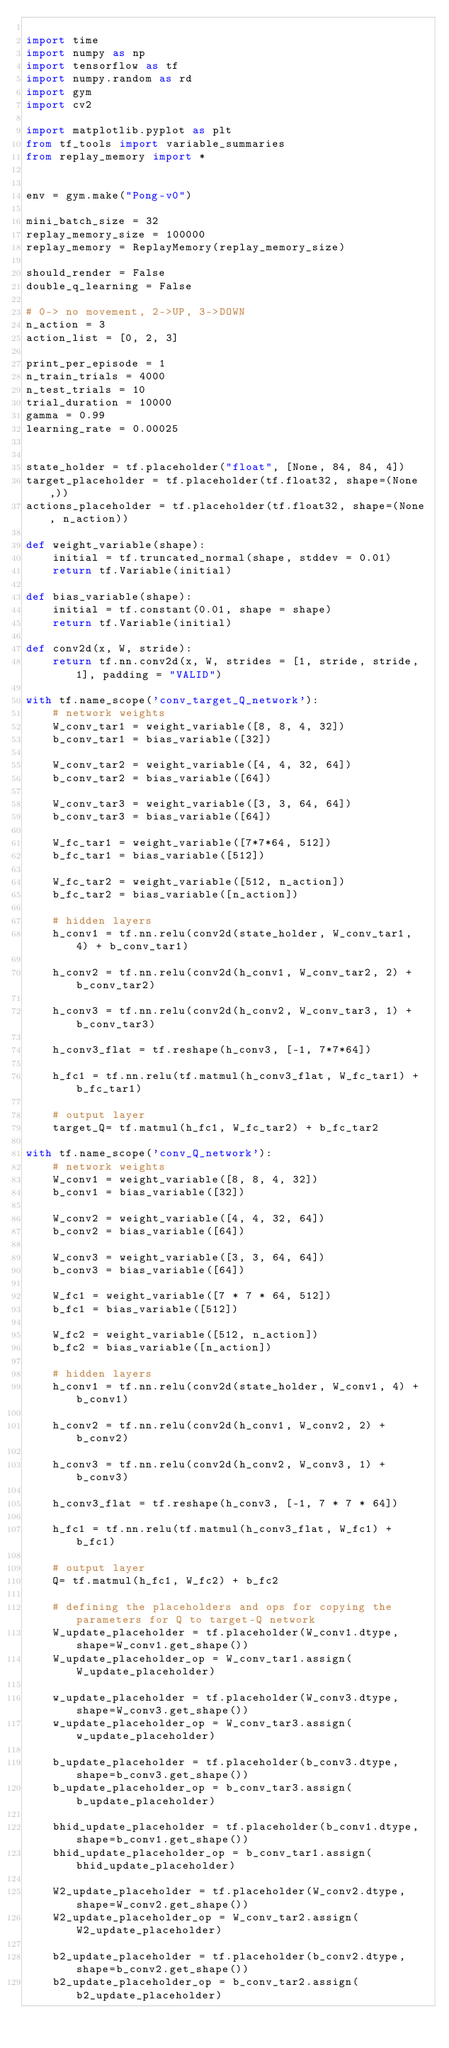Convert code to text. <code><loc_0><loc_0><loc_500><loc_500><_Python_>
import time
import numpy as np
import tensorflow as tf
import numpy.random as rd
import gym
import cv2

import matplotlib.pyplot as plt
from tf_tools import variable_summaries
from replay_memory import *


env = gym.make("Pong-v0")

mini_batch_size = 32
replay_memory_size = 100000
replay_memory = ReplayMemory(replay_memory_size)

should_render = False
double_q_learning = False

# 0-> no movement, 2->UP, 3->DOWN
n_action = 3
action_list = [0, 2, 3]

print_per_episode = 1
n_train_trials = 4000
n_test_trials = 10
trial_duration = 10000
gamma = 0.99
learning_rate = 0.00025


state_holder = tf.placeholder("float", [None, 84, 84, 4])
target_placeholder = tf.placeholder(tf.float32, shape=(None,))
actions_placeholder = tf.placeholder(tf.float32, shape=(None, n_action))

def weight_variable(shape):
    initial = tf.truncated_normal(shape, stddev = 0.01)
    return tf.Variable(initial)

def bias_variable(shape):
    initial = tf.constant(0.01, shape = shape)
    return tf.Variable(initial)

def conv2d(x, W, stride):
    return tf.nn.conv2d(x, W, strides = [1, stride, stride, 1], padding = "VALID")

with tf.name_scope('conv_target_Q_network'):
    # network weights
    W_conv_tar1 = weight_variable([8, 8, 4, 32])
    b_conv_tar1 = bias_variable([32])

    W_conv_tar2 = weight_variable([4, 4, 32, 64])
    b_conv_tar2 = bias_variable([64])

    W_conv_tar3 = weight_variable([3, 3, 64, 64])
    b_conv_tar3 = bias_variable([64])

    W_fc_tar1 = weight_variable([7*7*64, 512])
    b_fc_tar1 = bias_variable([512])

    W_fc_tar2 = weight_variable([512, n_action])
    b_fc_tar2 = bias_variable([n_action])

    # hidden layers
    h_conv1 = tf.nn.relu(conv2d(state_holder, W_conv_tar1, 4) + b_conv_tar1)

    h_conv2 = tf.nn.relu(conv2d(h_conv1, W_conv_tar2, 2) + b_conv_tar2)

    h_conv3 = tf.nn.relu(conv2d(h_conv2, W_conv_tar3, 1) + b_conv_tar3)

    h_conv3_flat = tf.reshape(h_conv3, [-1, 7*7*64])

    h_fc1 = tf.nn.relu(tf.matmul(h_conv3_flat, W_fc_tar1) + b_fc_tar1)

    # output layer
    target_Q= tf.matmul(h_fc1, W_fc_tar2) + b_fc_tar2

with tf.name_scope('conv_Q_network'):
    # network weights
    W_conv1 = weight_variable([8, 8, 4, 32])
    b_conv1 = bias_variable([32])

    W_conv2 = weight_variable([4, 4, 32, 64])
    b_conv2 = bias_variable([64])

    W_conv3 = weight_variable([3, 3, 64, 64])
    b_conv3 = bias_variable([64])

    W_fc1 = weight_variable([7 * 7 * 64, 512])
    b_fc1 = bias_variable([512])

    W_fc2 = weight_variable([512, n_action])
    b_fc2 = bias_variable([n_action])

    # hidden layers
    h_conv1 = tf.nn.relu(conv2d(state_holder, W_conv1, 4) + b_conv1)

    h_conv2 = tf.nn.relu(conv2d(h_conv1, W_conv2, 2) + b_conv2)

    h_conv3 = tf.nn.relu(conv2d(h_conv2, W_conv3, 1) + b_conv3)

    h_conv3_flat = tf.reshape(h_conv3, [-1, 7 * 7 * 64])

    h_fc1 = tf.nn.relu(tf.matmul(h_conv3_flat, W_fc1) + b_fc1)

    # output layer
    Q= tf.matmul(h_fc1, W_fc2) + b_fc2

    # defining the placeholders and ops for copying the parameters for Q to target-Q network
    W_update_placeholder = tf.placeholder(W_conv1.dtype, shape=W_conv1.get_shape())
    W_update_placeholder_op = W_conv_tar1.assign(W_update_placeholder)

    w_update_placeholder = tf.placeholder(W_conv3.dtype, shape=W_conv3.get_shape())
    w_update_placeholder_op = W_conv_tar3.assign(w_update_placeholder)

    b_update_placeholder = tf.placeholder(b_conv3.dtype, shape=b_conv3.get_shape())
    b_update_placeholder_op = b_conv_tar3.assign(b_update_placeholder)

    bhid_update_placeholder = tf.placeholder(b_conv1.dtype, shape=b_conv1.get_shape())
    bhid_update_placeholder_op = b_conv_tar1.assign(bhid_update_placeholder)

    W2_update_placeholder = tf.placeholder(W_conv2.dtype, shape=W_conv2.get_shape())
    W2_update_placeholder_op = W_conv_tar2.assign(W2_update_placeholder)

    b2_update_placeholder = tf.placeholder(b_conv2.dtype, shape=b_conv2.get_shape())
    b2_update_placeholder_op = b_conv_tar2.assign(b2_update_placeholder)
</code> 